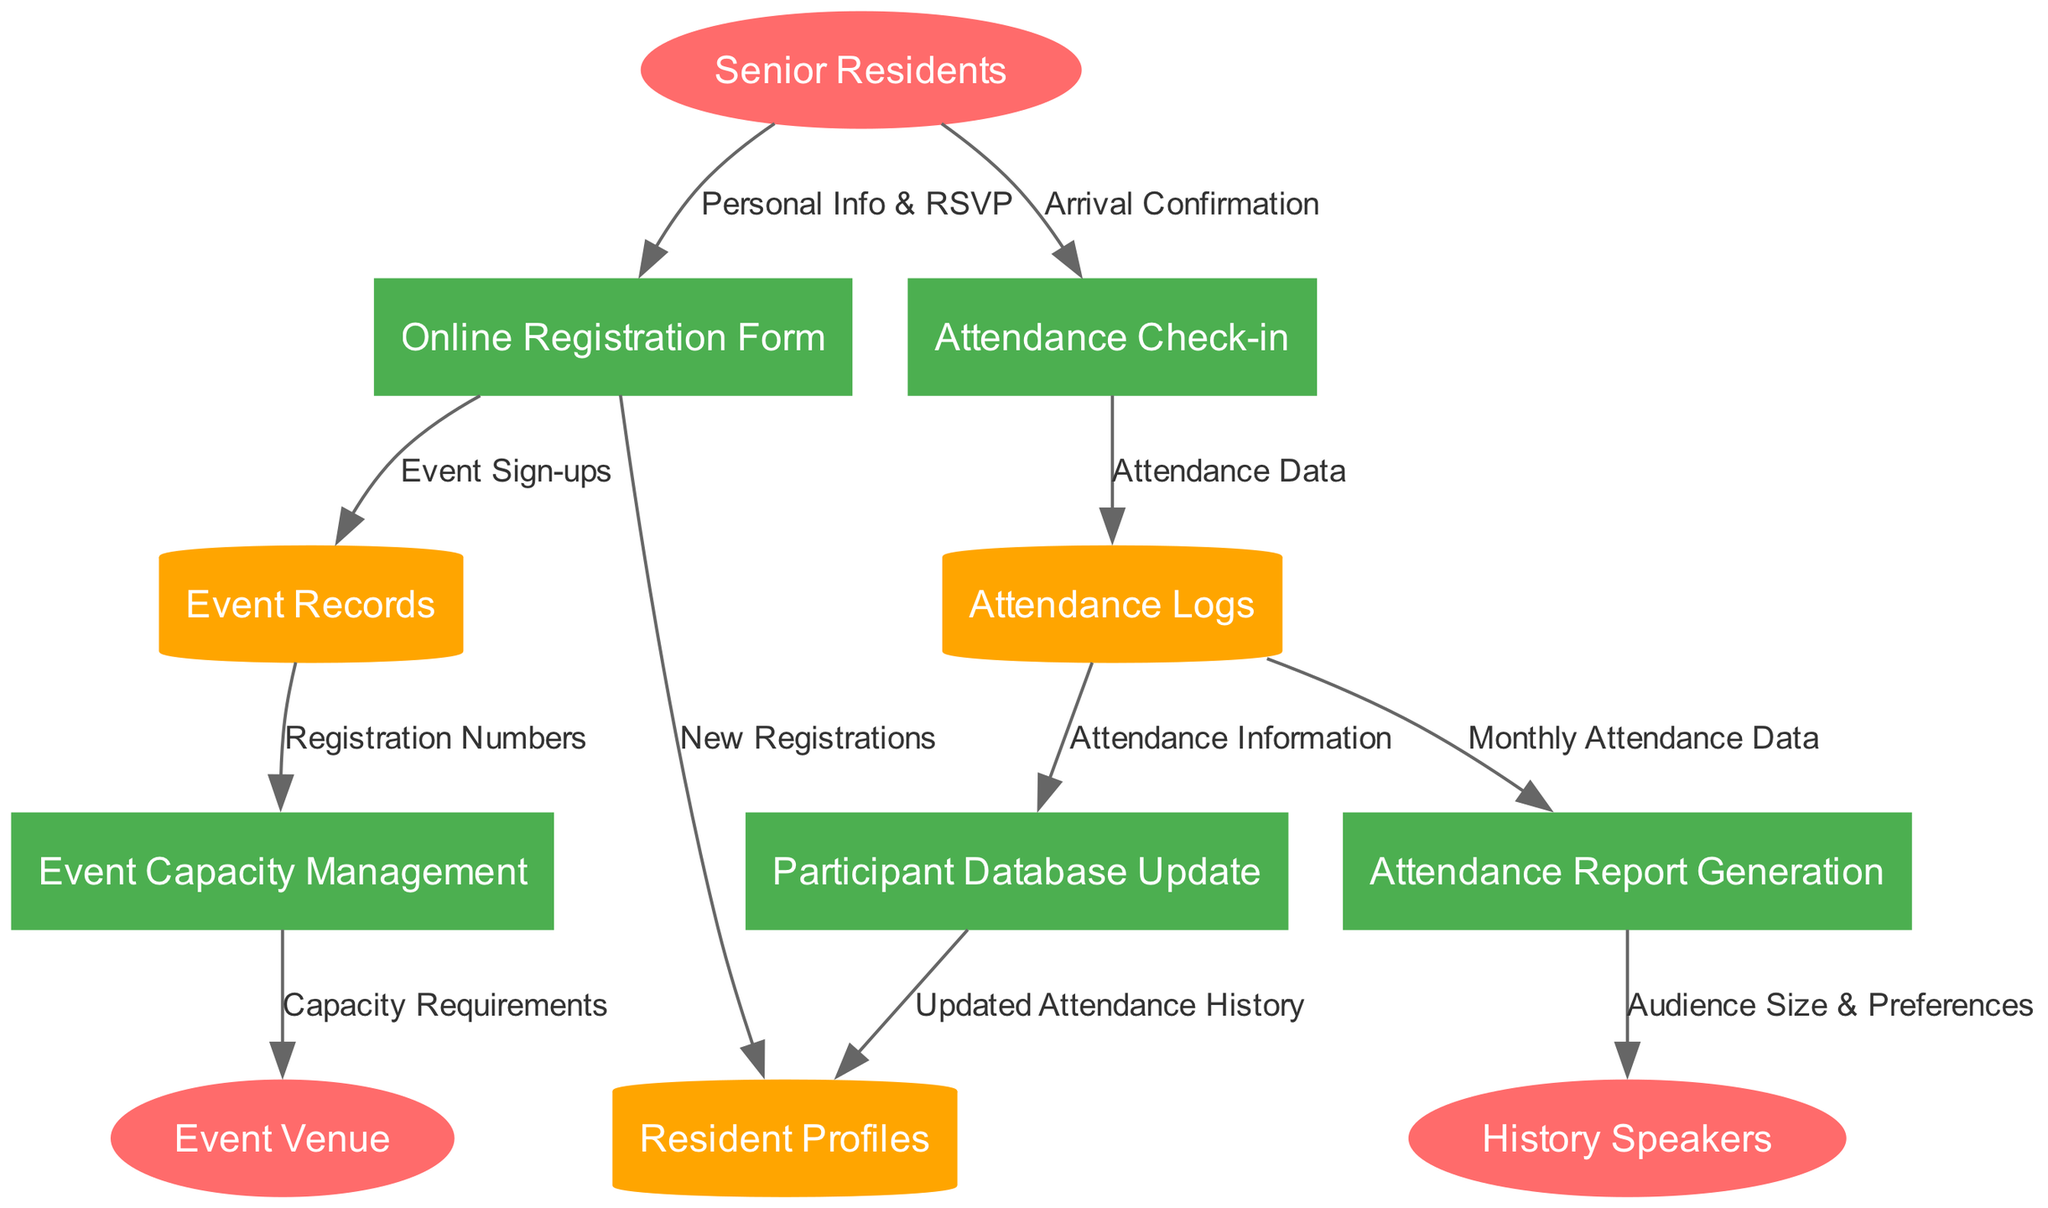What are the external entities in this diagram? The external entities are represented by ellipses in the diagram. They include "Senior Residents," "History Speakers," and "Event Venue."
Answer: Senior Residents, History Speakers, Event Venue How many processes are illustrated in the diagram? The processes are indicated by rectangles. There are five processes listed, which are "Online Registration Form," "Attendance Check-in," "Participant Database Update," "Event Capacity Management," and "Attendance Report Generation."
Answer: Five What flows out of the "Attendance Check-in" process? The flow from "Attendance Check-in" goes to "Attendance Logs," carrying "Attendance Data," and the subsequent flow to "Participant Database Update," carrying "Attendance Information."
Answer: Attendance Data, Attendance Information What data store is updated as a result of the "Participant Database Update" process? The "Participant Database Update" process updates the "Resident Profiles" data store, specifically reflecting any changes made to the attendance history.
Answer: Resident Profiles Which external entity receives the "Audience Size & Preferences" from the "Attendance Report Generation"? The "Attendance Report Generation" process outputs "Audience Size & Preferences" to the external entity "History Speakers."
Answer: History Speakers What is the flow labeled from "Event Records" to "Event Capacity Management"? The flow carries "Registration Numbers" from "Event Records" to "Event Capacity Management," indicating the current number of people signed up for the event.
Answer: Registration Numbers How does "Attendance Logs" contribute to the "Attendance Report Generation"? "Attendance Logs" provide "Monthly Attendance Data" to the "Attendance Report Generation," enabling the creation of reports based on attendee participation throughout the month.
Answer: Monthly Attendance Data How many data stores are present in the diagram? The data stores are represented by cylinders in the diagram, and there are three specified: "Resident Profiles," "Event Records," and "Attendance Logs."
Answer: Three What type of diagram is being analyzed here? This diagram is specifically a Data Flow Diagram (DFD), which outlines the flow of information within the registration and attendance tracking system for the monthly gatherings.
Answer: Data Flow Diagram 